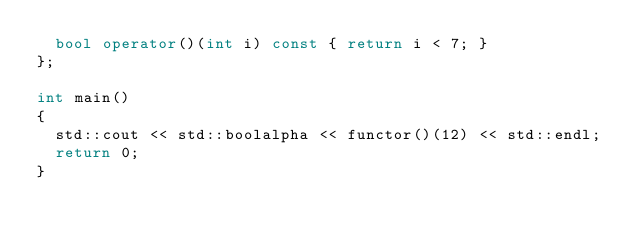<code> <loc_0><loc_0><loc_500><loc_500><_C++_>  bool operator()(int i) const { return i < 7; }
};

int main()
{
  std::cout << std::boolalpha << functor()(12) << std::endl;
  return 0;
}
</code> 